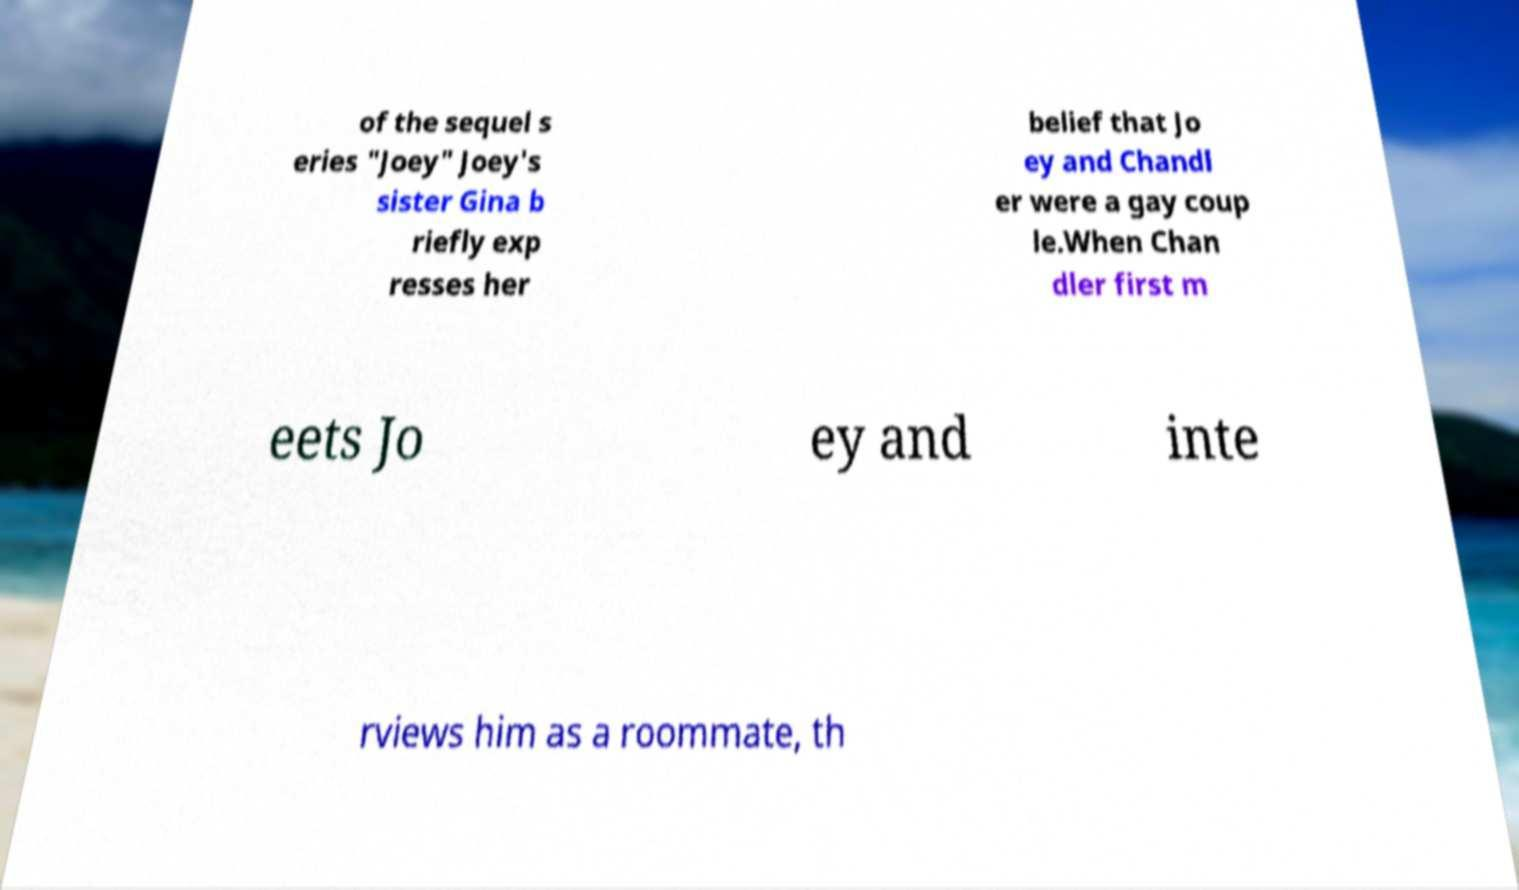Can you accurately transcribe the text from the provided image for me? of the sequel s eries "Joey" Joey's sister Gina b riefly exp resses her belief that Jo ey and Chandl er were a gay coup le.When Chan dler first m eets Jo ey and inte rviews him as a roommate, th 